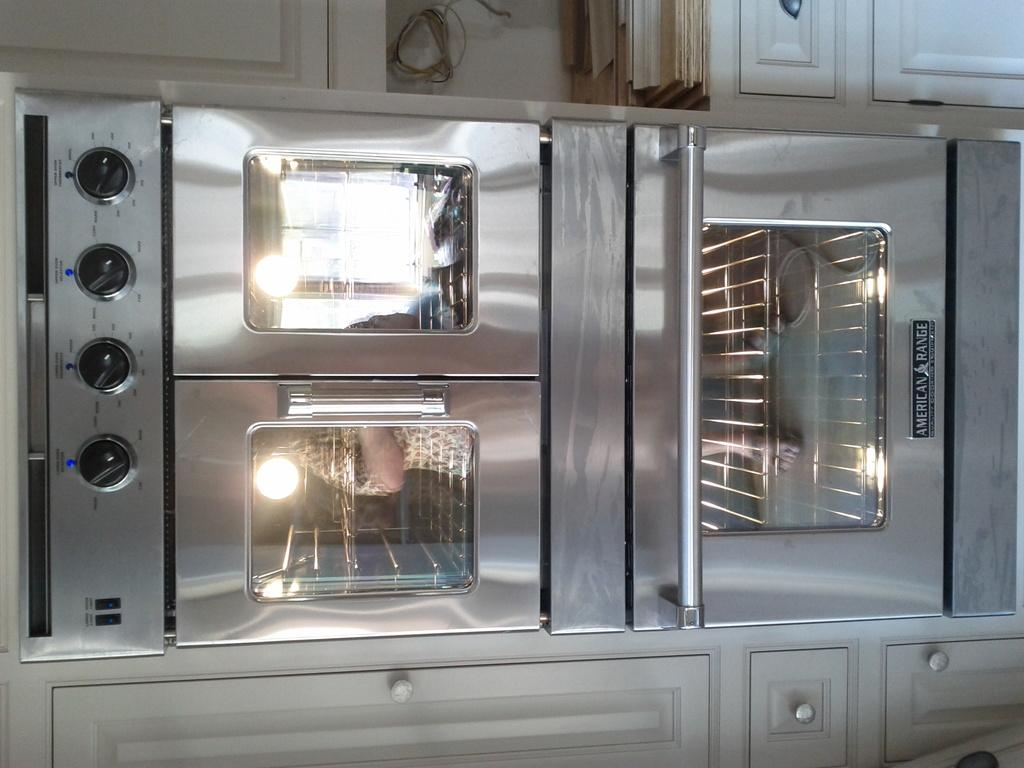What is the main subject of the image? There is an object in the image. What is located above the object in the image? There are cupboards above the object. What is located below the object in the image? There are cupboards below the object. How many feet are visible on the roof in the image? There is no roof or feet present in the image. What route is the object taking in the image? The object is not moving or taking a route in the image; it is stationary. 